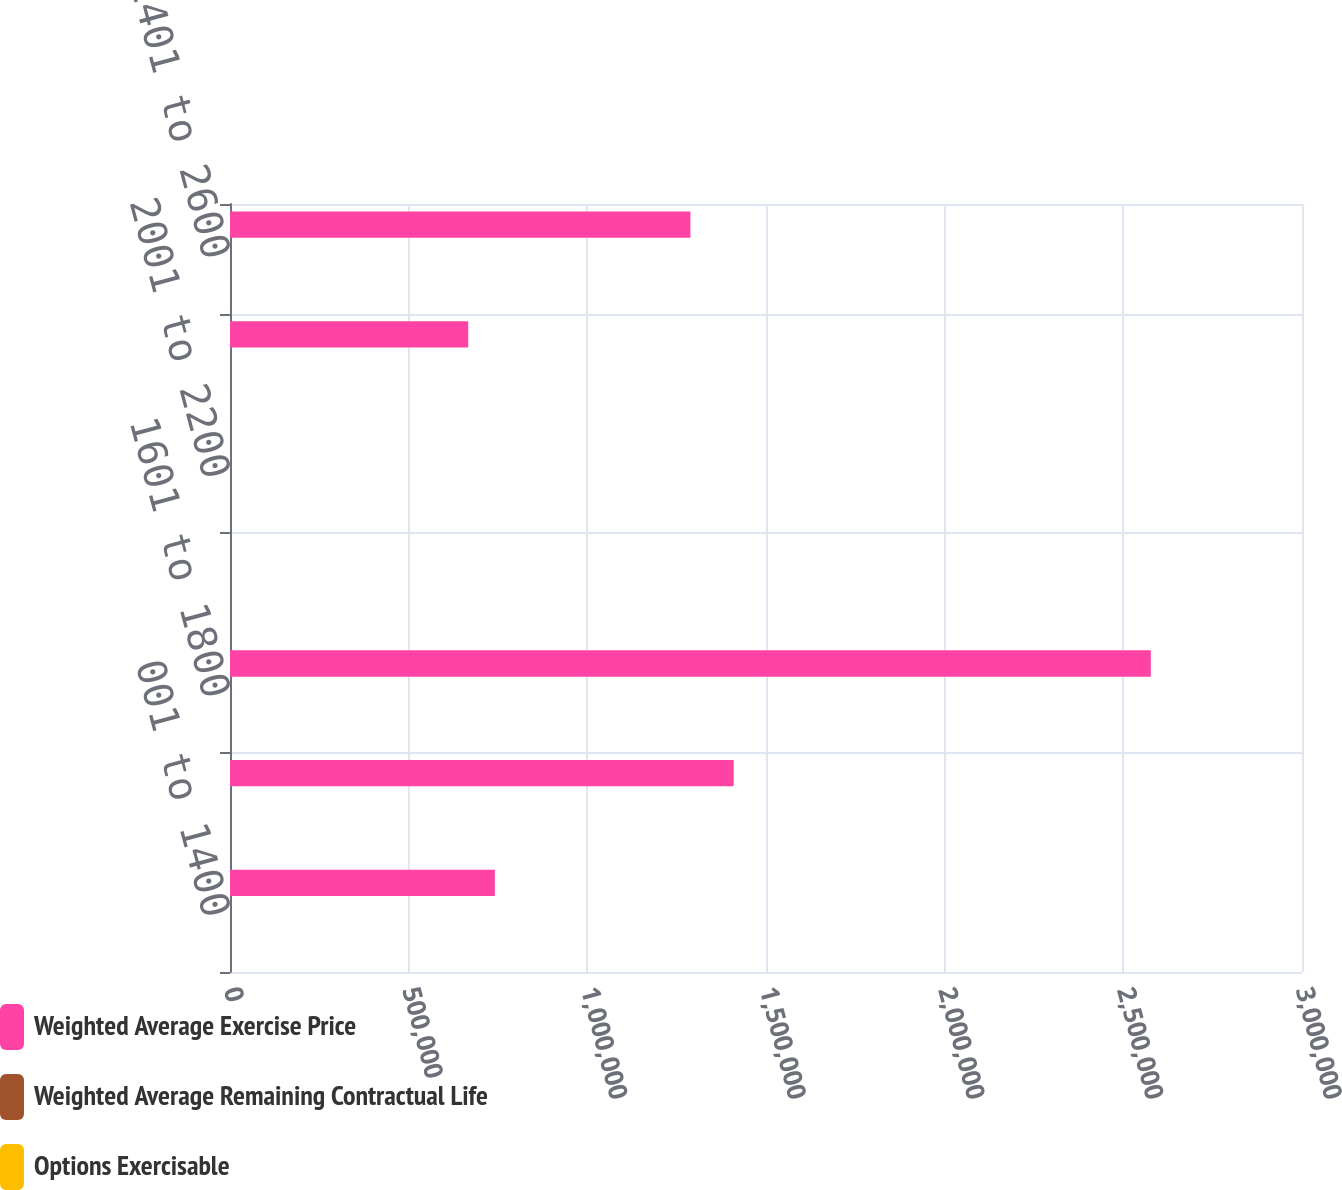Convert chart to OTSL. <chart><loc_0><loc_0><loc_500><loc_500><stacked_bar_chart><ecel><fcel>001 to 1400<fcel>1401 to 1600<fcel>1601 to 1800<fcel>1801 to 2000<fcel>2001 to 2200<fcel>2201 to 2400<fcel>2401 to 2600<nl><fcel>Weighted Average Exercise Price<fcel>741180<fcel>1.40956e+06<fcel>2.57687e+06<fcel>17.46<fcel>17.46<fcel>666672<fcel>1.2885e+06<nl><fcel>Weighted Average Remaining Contractual Life<fcel>3.7<fcel>3.83<fcel>4.24<fcel>5.76<fcel>3.16<fcel>7.66<fcel>0.3<nl><fcel>Options Exercisable<fcel>13.68<fcel>15.86<fcel>17.46<fcel>18.71<fcel>20.76<fcel>22.76<fcel>24.39<nl></chart> 